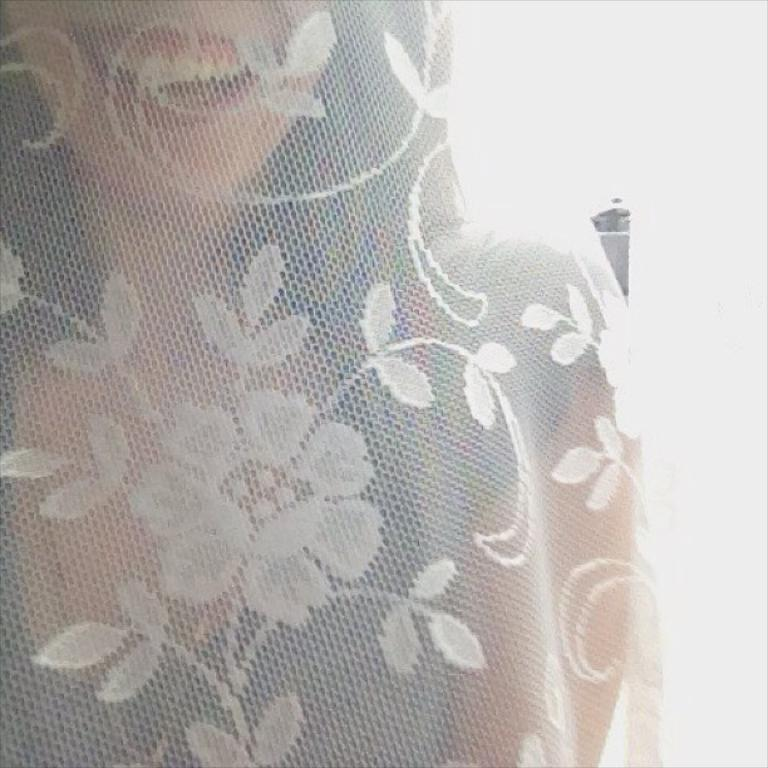Who is present in the image? There is a woman in the image. What is the woman doing or where is she located in the image? The woman is behind a cloth in the image. Can you describe the cloth that the woman is behind? The cloth has flowers and leaves on it. What type of furniture is visible in the image? There is no furniture present in the image; it features a woman behind a cloth with flowers and leaves on it. What kind of fuel is being used by the woman in the image? There is no mention of any fuel or its use in the image; it shows a woman behind a cloth with flowers and leaves on it. 